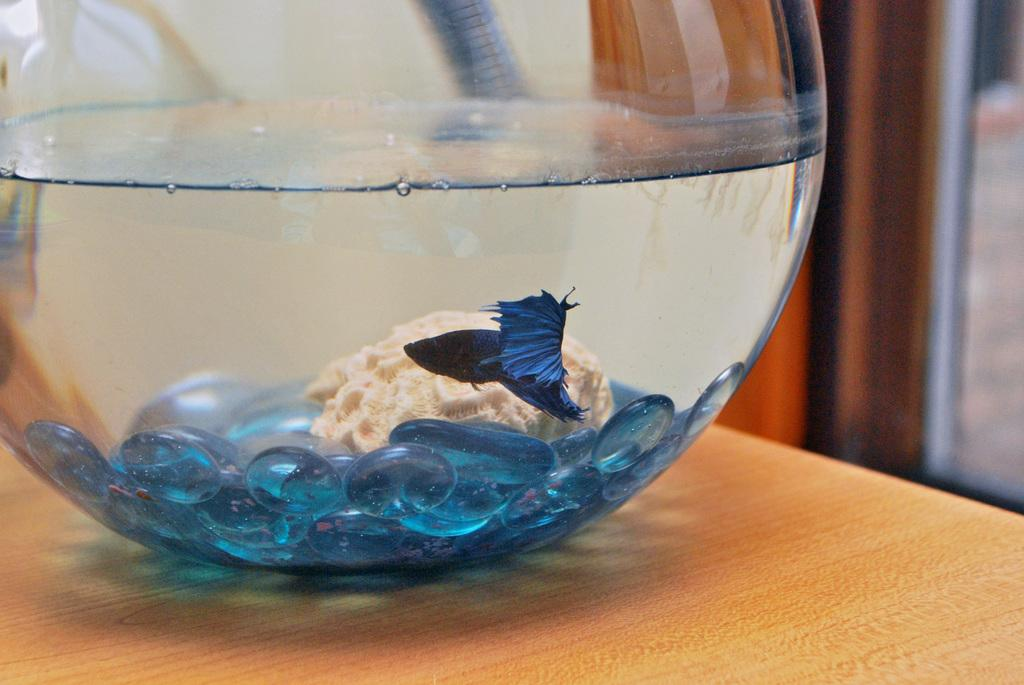What is in the bowl that is visible in the image? There is a bowl with water in the image. What type of fish is in the bowl? There is a fighter fish in the bowl. What decorative elements are in the bowl? There are blue color stones in the bowl. What is the unspecified object in the bowl? The image only mentions that there is another unspecified object in the bowl, but it does not provide any details about it. On what surface is the bowl placed? The bowl is placed on a wooden surface. What type of breakfast is being served in the image? There is no breakfast visible in the image; it features a bowl with water, a fighter fish, blue color stones, and an unspecified object. What type of cave can be seen in the image? There is no cave present in the image; it features a bowl with water, a fighter fish, blue color stones, and an unspecified object. 